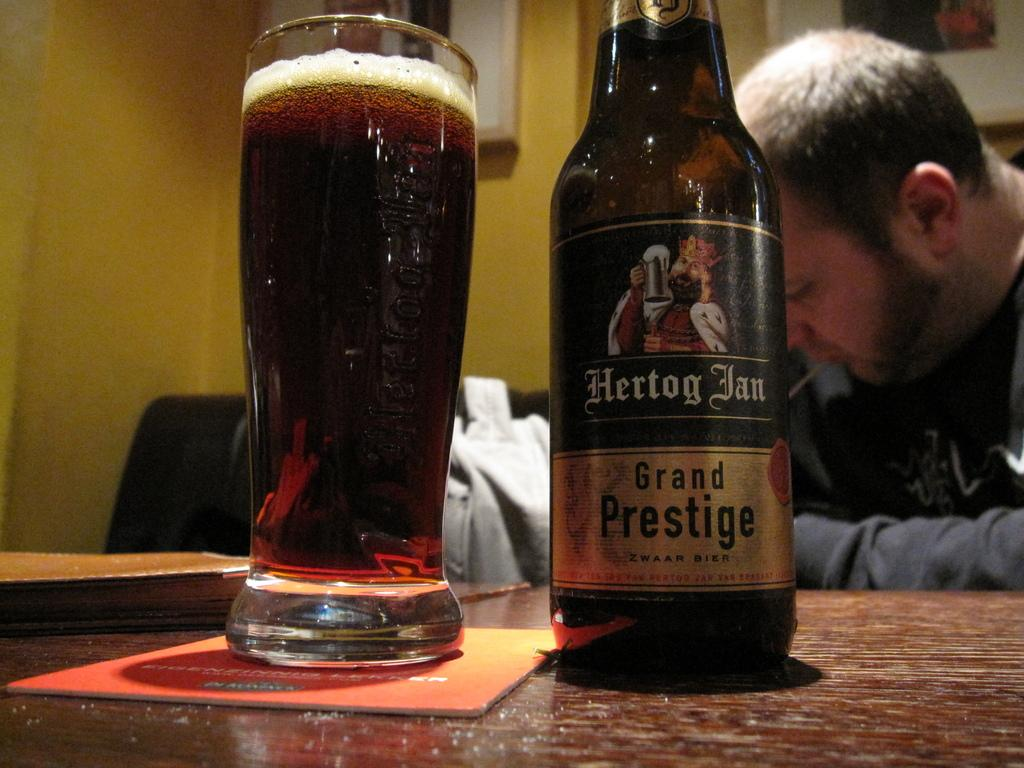<image>
Describe the image concisely. A bottle of Hertog Fan Grand Prestige beer sits next to a glass for of beer. 